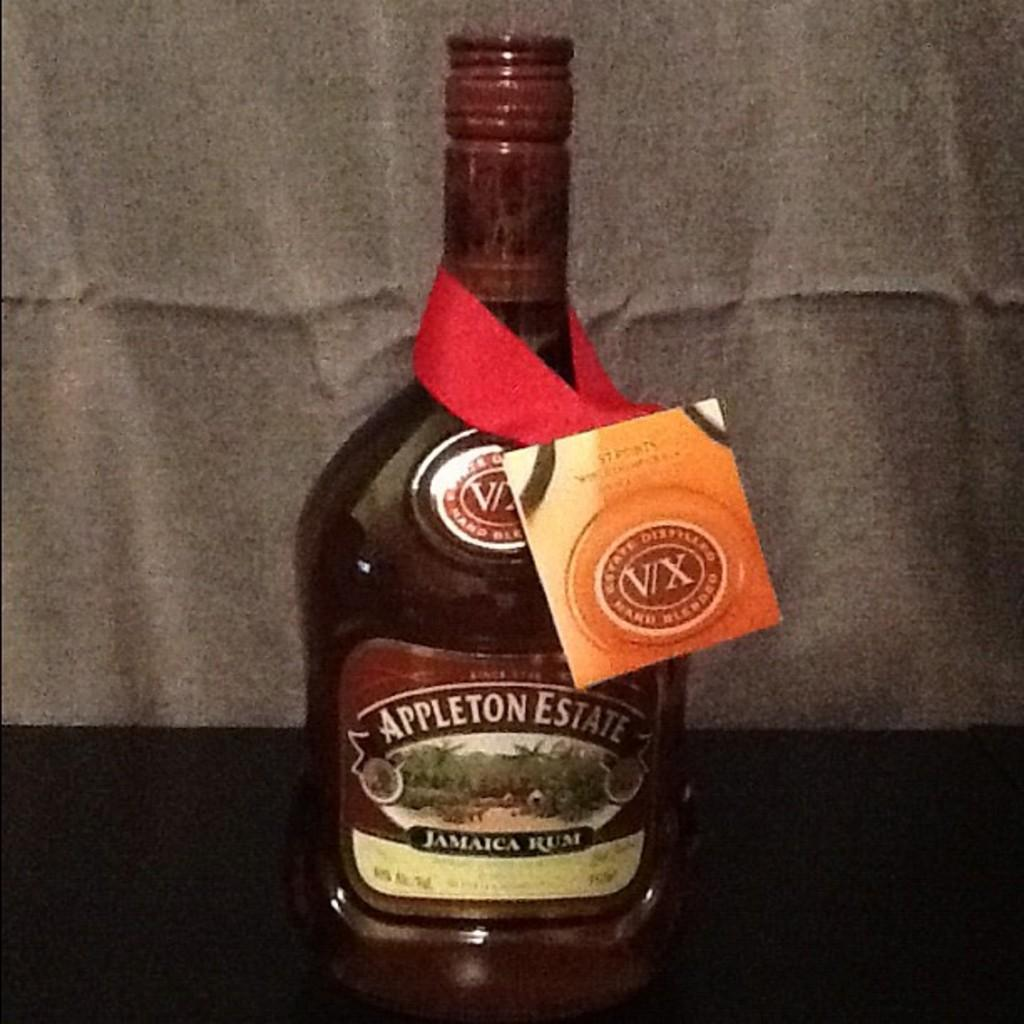<image>
Relay a brief, clear account of the picture shown. A bottle of Jamaican rum from Appleton Estates. 